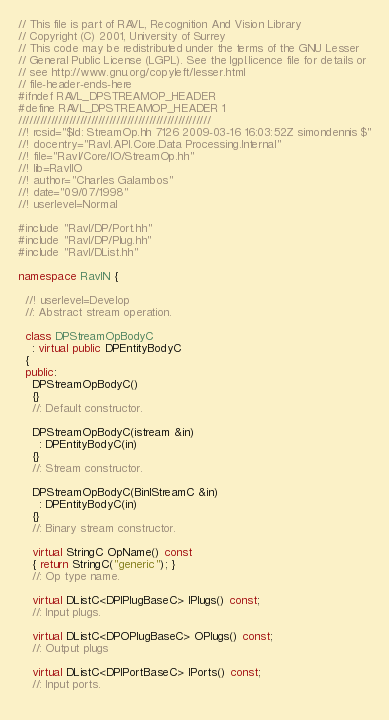Convert code to text. <code><loc_0><loc_0><loc_500><loc_500><_C++_>// This file is part of RAVL, Recognition And Vision Library 
// Copyright (C) 2001, University of Surrey
// This code may be redistributed under the terms of the GNU Lesser
// General Public License (LGPL). See the lgpl.licence file for details or
// see http://www.gnu.org/copyleft/lesser.html
// file-header-ends-here
#ifndef RAVL_DPSTREAMOP_HEADER
#define RAVL_DPSTREAMOP_HEADER 1
/////////////////////////////////////////////////////
//! rcsid="$Id: StreamOp.hh 7126 2009-03-16 16:03:52Z simondennis $"
//! docentry="Ravl.API.Core.Data Processing.Internal" 
//! file="Ravl/Core/IO/StreamOp.hh"
//! lib=RavlIO
//! author="Charles Galambos"
//! date="09/07/1998"
//! userlevel=Normal

#include "Ravl/DP/Port.hh"
#include "Ravl/DP/Plug.hh"
#include "Ravl/DList.hh"

namespace RavlN {
  
  //! userlevel=Develop
  //: Abstract stream operation.
  
  class DPStreamOpBodyC
    : virtual public DPEntityBodyC 
  {
  public:
    DPStreamOpBodyC()
    {}
    //: Default constructor.
    
    DPStreamOpBodyC(istream &in) 
      : DPEntityBodyC(in)
    {}
    //: Stream constructor.
    
    DPStreamOpBodyC(BinIStreamC &in) 
      : DPEntityBodyC(in)
    {}
    //: Binary stream constructor.

    virtual StringC OpName() const
    { return StringC("generic"); }
    //: Op type name.
    
    virtual DListC<DPIPlugBaseC> IPlugs() const;
    //: Input plugs.
    
    virtual DListC<DPOPlugBaseC> OPlugs() const;
    //: Output plugs
    
    virtual DListC<DPIPortBaseC> IPorts() const;
    //: Input ports.
    </code> 